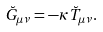<formula> <loc_0><loc_0><loc_500><loc_500>\breve { G } _ { \mu \nu } = - \kappa \breve { T } _ { \mu \nu } .</formula> 